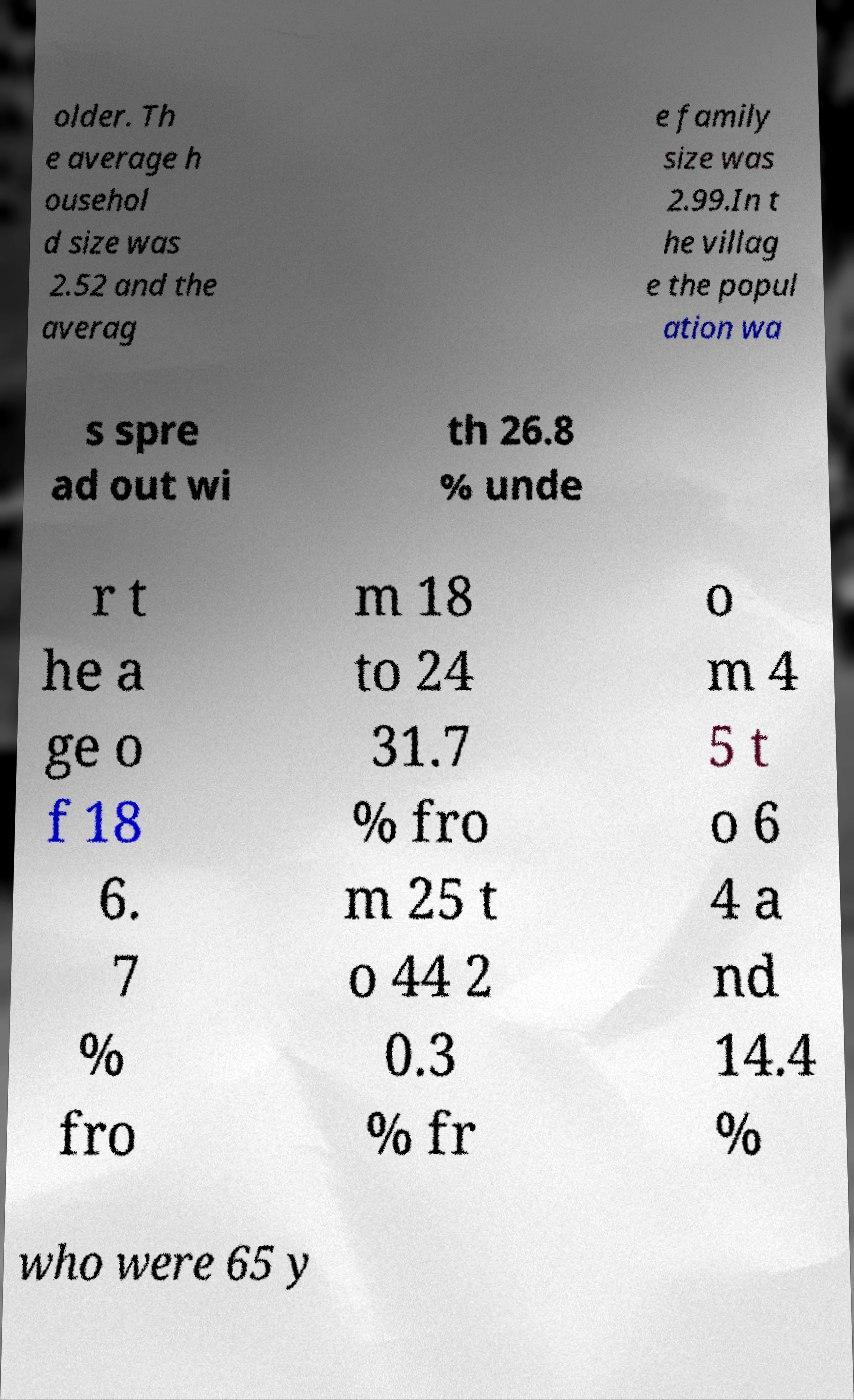Please identify and transcribe the text found in this image. older. Th e average h ousehol d size was 2.52 and the averag e family size was 2.99.In t he villag e the popul ation wa s spre ad out wi th 26.8 % unde r t he a ge o f 18 6. 7 % fro m 18 to 24 31.7 % fro m 25 t o 44 2 0.3 % fr o m 4 5 t o 6 4 a nd 14.4 % who were 65 y 